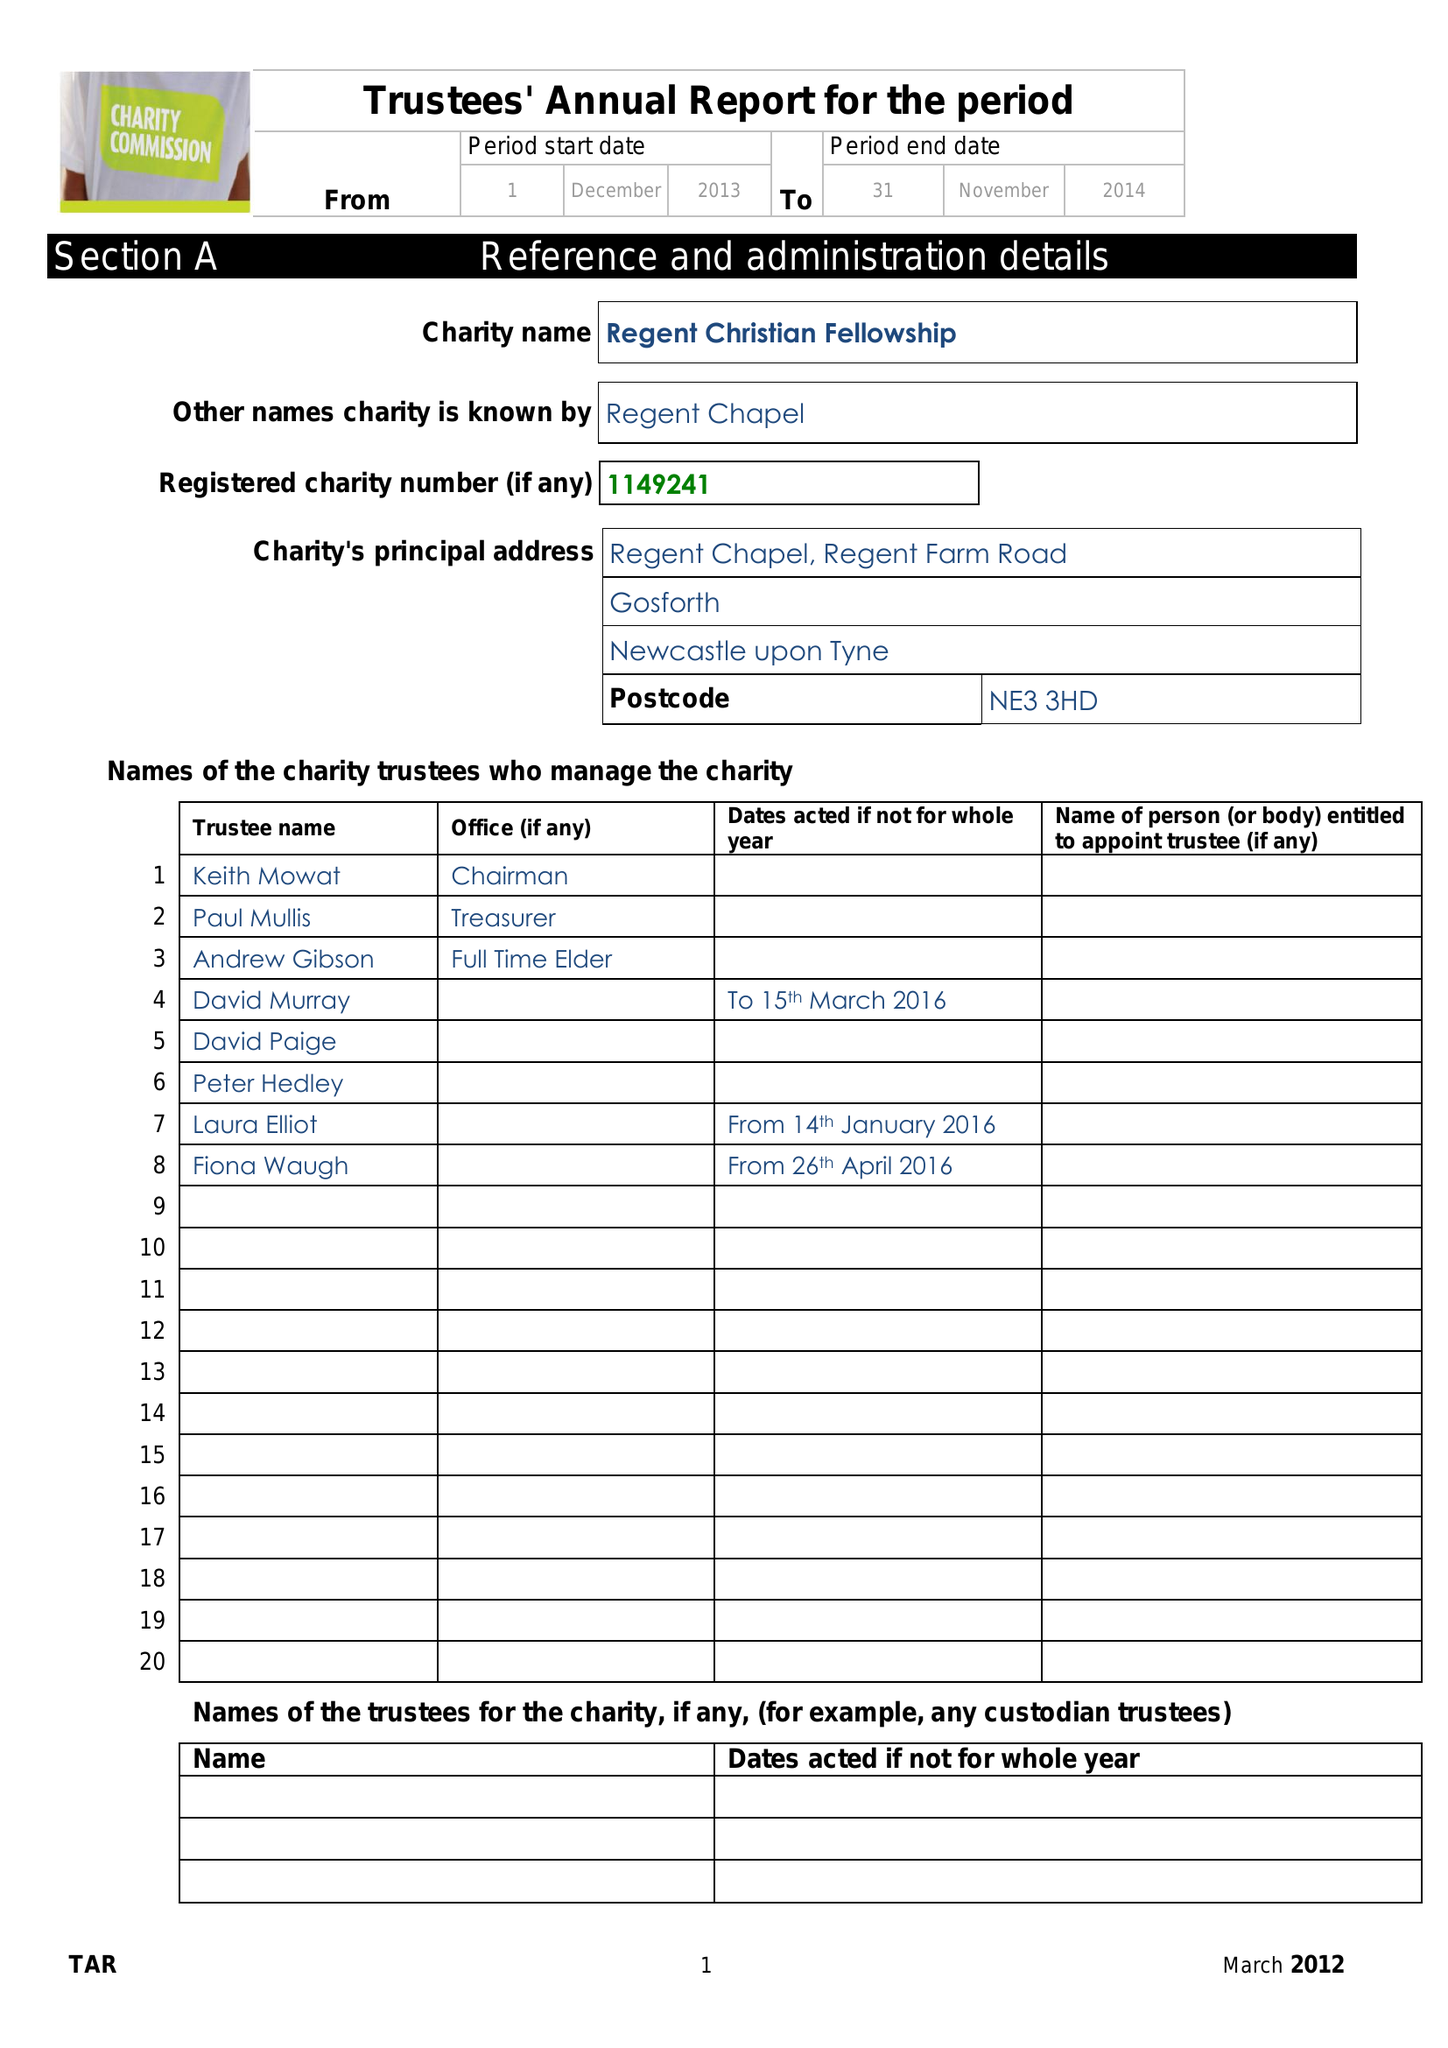What is the value for the address__street_line?
Answer the question using a single word or phrase. REGENT FARM ROAD 